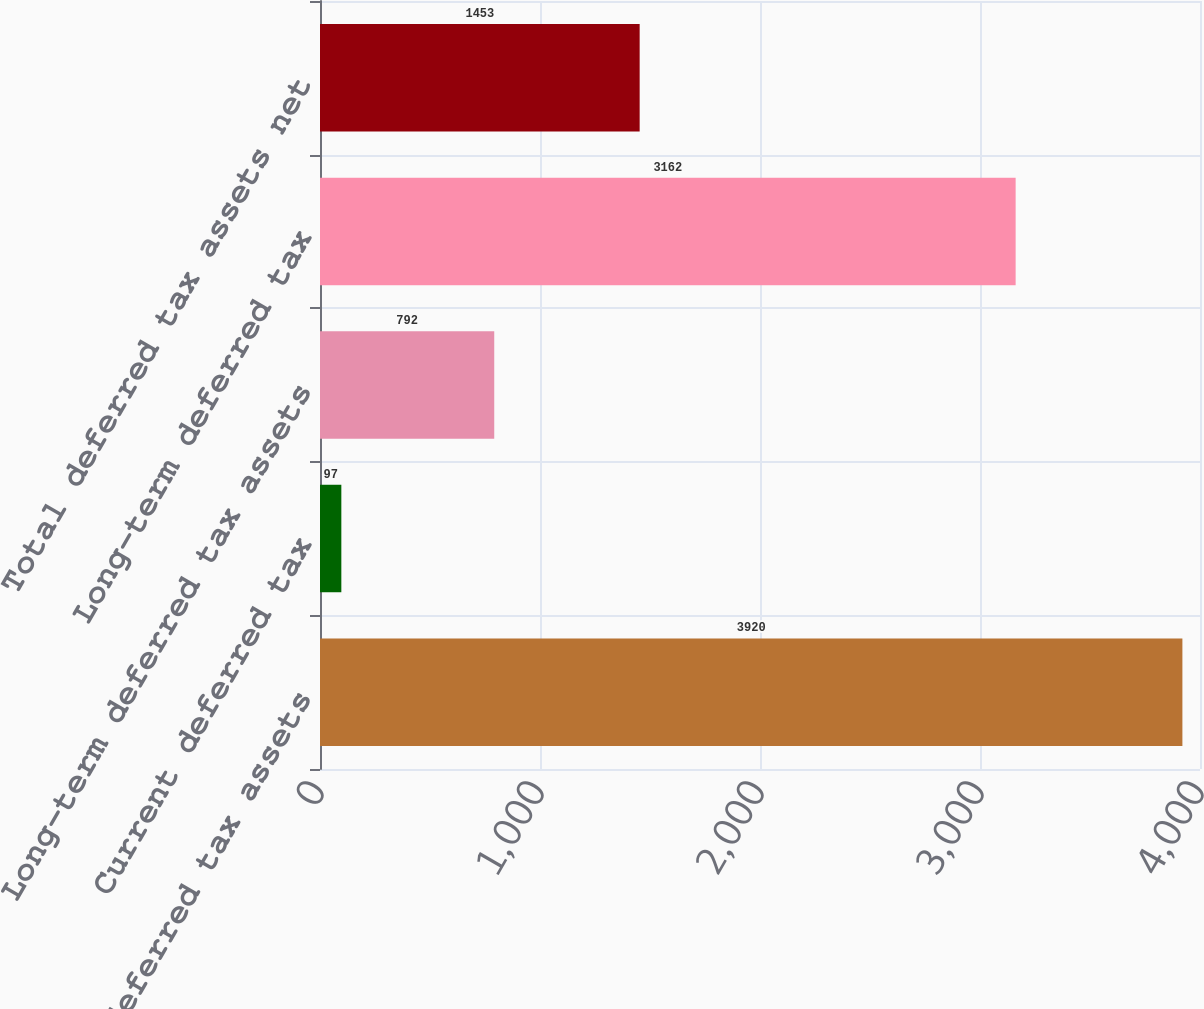<chart> <loc_0><loc_0><loc_500><loc_500><bar_chart><fcel>Current deferred tax assets<fcel>Current deferred tax<fcel>Long-term deferred tax assets<fcel>Long-term deferred tax<fcel>Total deferred tax assets net<nl><fcel>3920<fcel>97<fcel>792<fcel>3162<fcel>1453<nl></chart> 